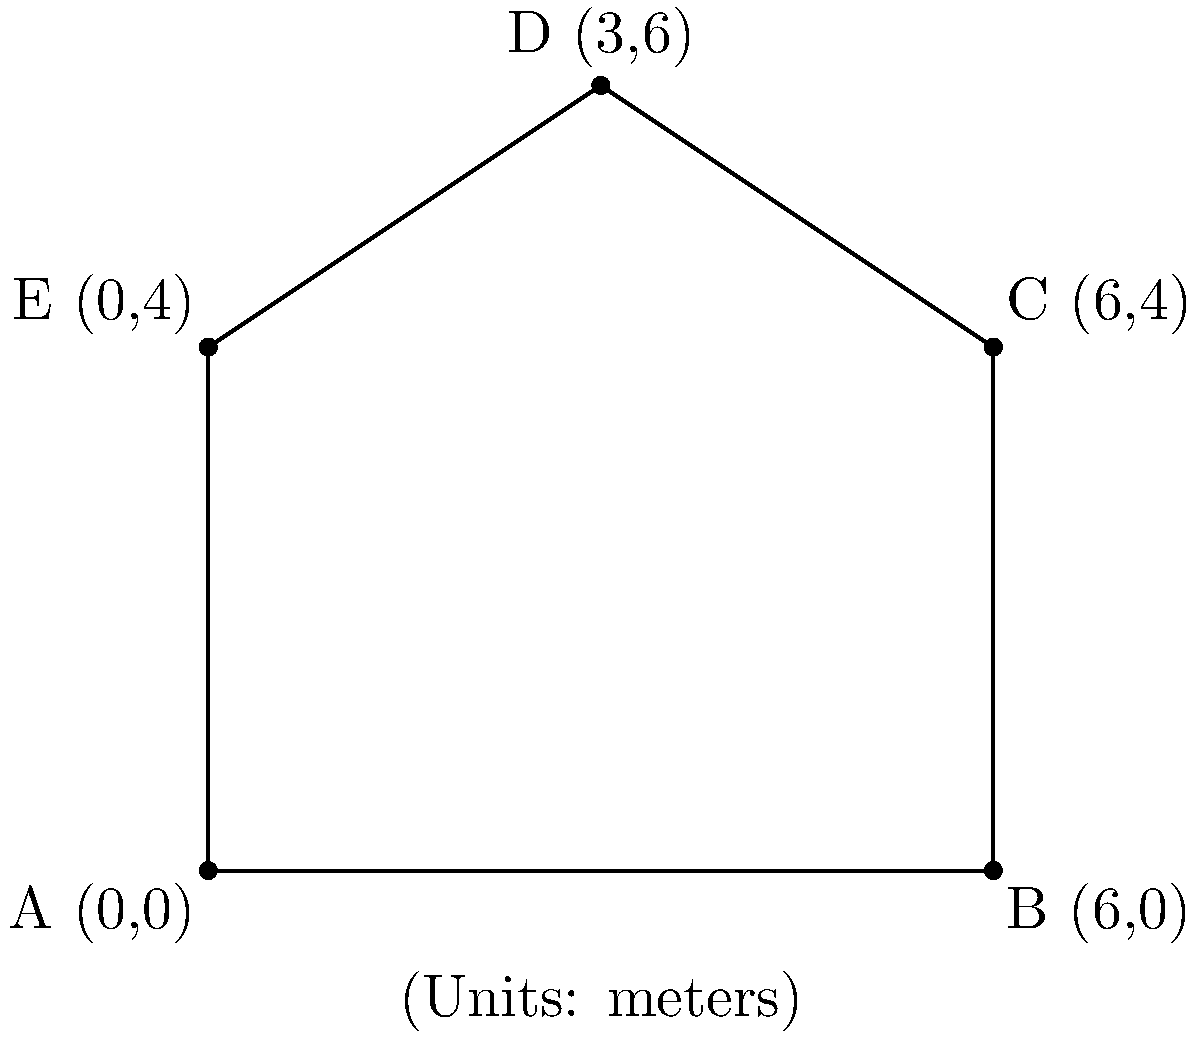A complex metal structure for a custom art installation is represented by the shape ABCDE in the coordinate plane. Each point represents a joint where different metal pieces connect. Given the coordinates of the vertices A(0,0), B(6,0), C(6,4), D(3,6), and E(0,4) in meters, determine the coordinates of the center of mass for this structure. Assume the structure has uniform density throughout. To find the center of mass for a uniform density planar shape:

1. Calculate the x-coordinate of the center of mass:
   $$x_{cm} = \frac{\sum_{i=1}^n x_i}{n}$$

2. Calculate the y-coordinate of the center of mass:
   $$y_{cm} = \frac{\sum_{i=1}^n y_i}{n}$$

Where $n$ is the number of vertices, and $(x_i, y_i)$ are the coordinates of each vertex.

For our shape:
$x$ coordinates: 0, 6, 6, 3, 0
$y$ coordinates: 0, 0, 4, 6, 4

$$x_{cm} = \frac{0 + 6 + 6 + 3 + 0}{5} = \frac{15}{5} = 3$$

$$y_{cm} = \frac{0 + 0 + 4 + 6 + 4}{5} = \frac{14}{5} = 2.8$$

Therefore, the center of mass is located at (3, 2.8) meters.
Answer: (3, 2.8) meters 